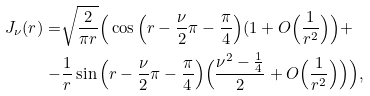<formula> <loc_0><loc_0><loc_500><loc_500>J _ { \nu } ( r ) = & \sqrt { \frac { 2 } { \pi r } } \Big ( \cos \Big ( r - \frac { \nu } { 2 } \pi - \frac { \pi } { 4 } \Big ) ( 1 + O \Big ( \frac { 1 } { r ^ { 2 } } \Big ) \Big ) + \\ - & \frac { 1 } { r } \sin \Big ( r - \frac { \nu } { 2 } \pi - \frac { \pi } { 4 } \Big ) \Big ( \frac { \nu ^ { 2 } - \frac { 1 } { 4 } } { 2 } + O \Big ( \frac { 1 } { r ^ { 2 } } \Big ) \Big ) \Big ) ,</formula> 